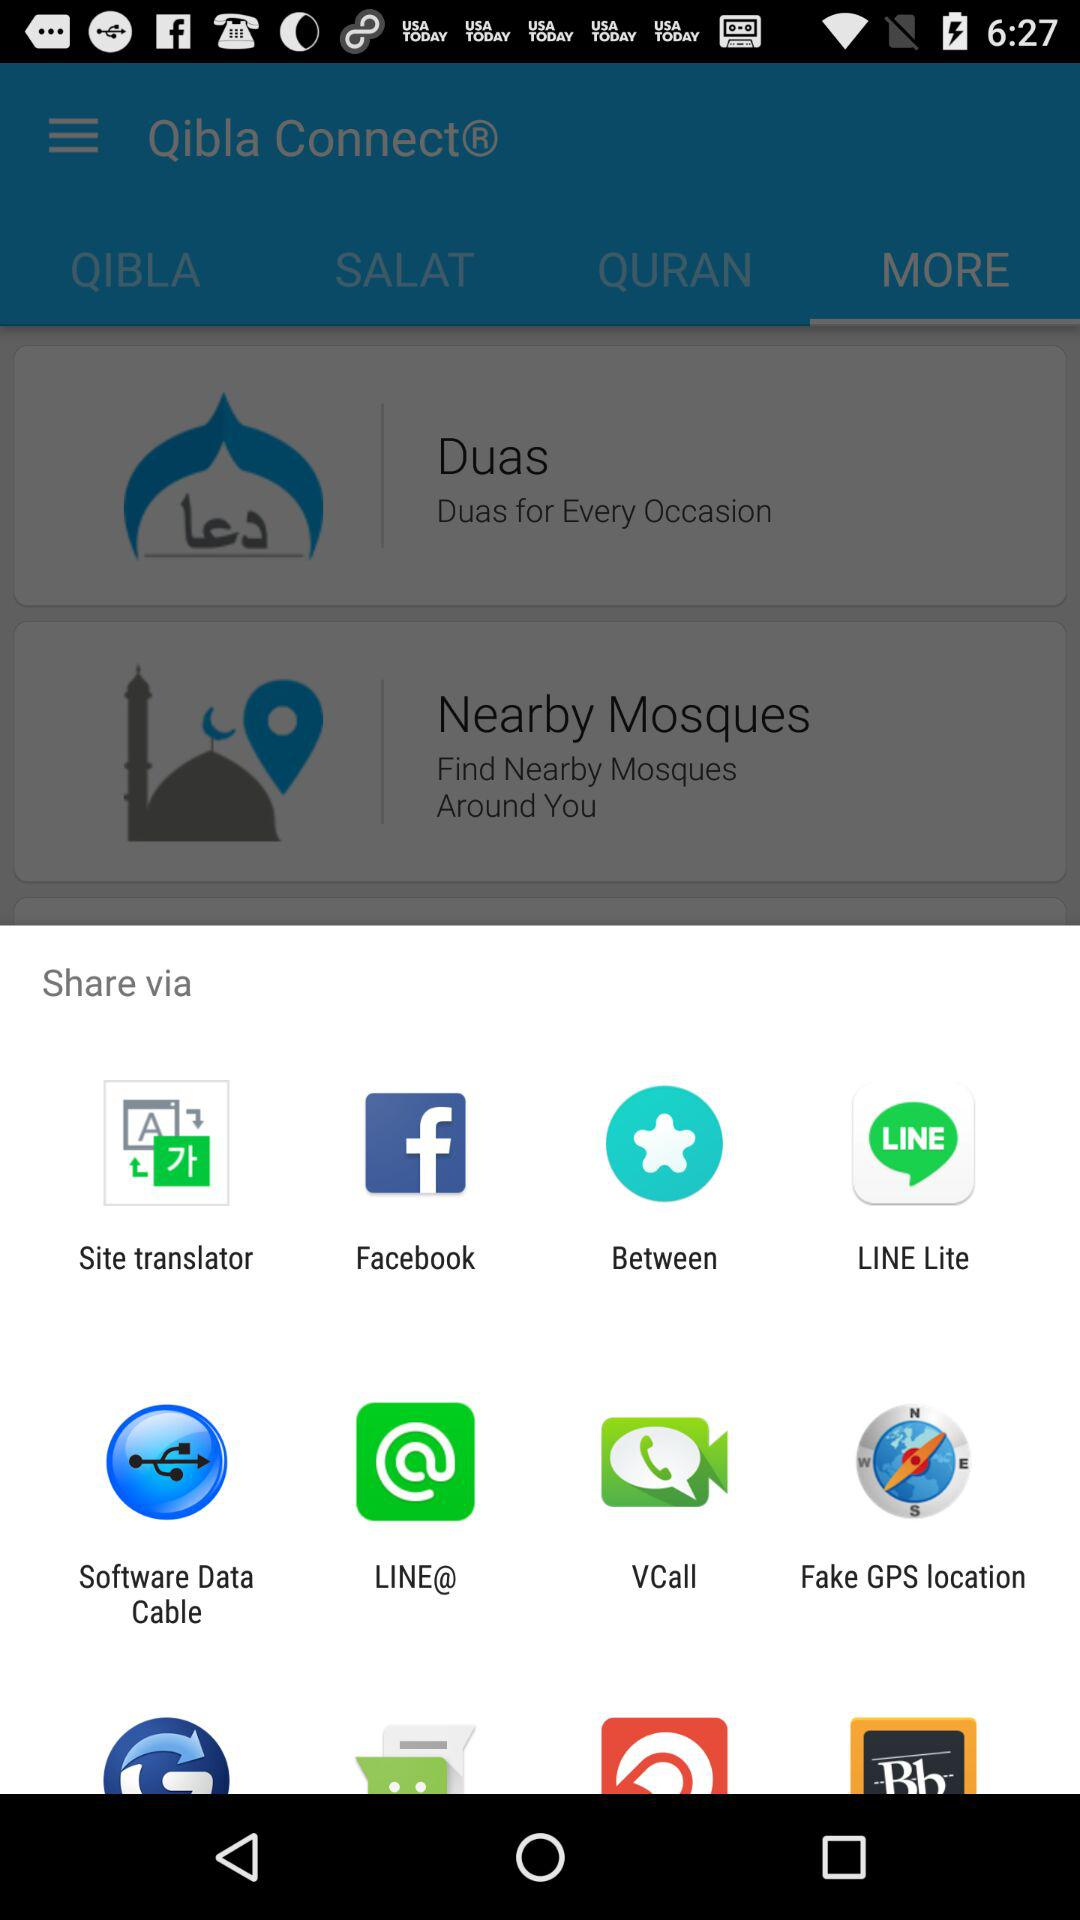Through which application can be shared? It can be shared through "Site translator", "Facebook", "Between", "LINE Lite", "Software Data Cable", "LINE@", "VCall", and "Fake GPS location". 